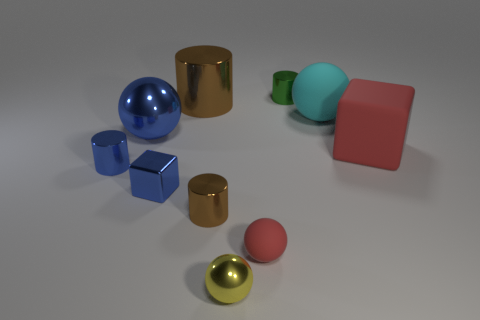Does the cyan rubber ball have the same size as the blue cube?
Offer a terse response. No. How many things are large matte cubes or tiny rubber cylinders?
Your answer should be very brief. 1. Is the number of metallic cylinders behind the large red object the same as the number of tiny green metallic cylinders?
Offer a terse response. No. Are there any small blue things right of the shiny sphere that is right of the brown cylinder behind the small blue shiny cylinder?
Give a very brief answer. No. The small object that is the same material as the large red block is what color?
Your answer should be very brief. Red. There is a small metal cylinder that is on the right side of the yellow sphere; does it have the same color as the large matte ball?
Your answer should be compact. No. How many blocks are either large rubber things or blue things?
Your answer should be compact. 2. There is a brown metal object that is behind the block that is right of the small cylinder behind the big blue thing; what size is it?
Your answer should be compact. Large. What shape is the yellow thing that is the same size as the metallic cube?
Offer a very short reply. Sphere. There is a tiny matte object; what shape is it?
Make the answer very short. Sphere. 